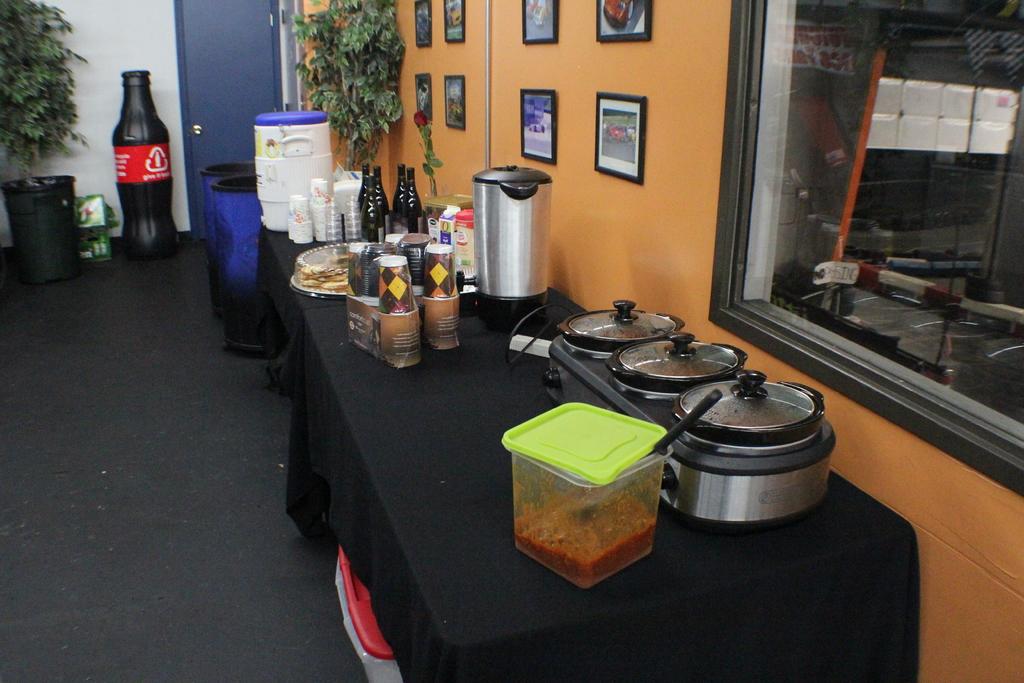What drink is in the cases by the trash can?
Offer a terse response. Coca cola. 